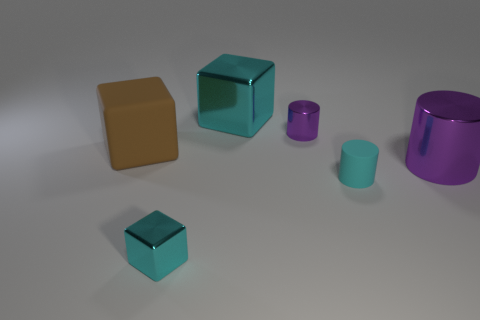Are the purple cylinder that is on the left side of the tiny cyan matte cylinder and the thing to the right of the small matte cylinder made of the same material?
Offer a very short reply. Yes. There is a big object behind the brown matte cube; is there a small cylinder that is behind it?
Your answer should be very brief. No. What color is the big cube that is the same material as the small cyan cylinder?
Your answer should be compact. Brown. Is the number of tiny purple shiny things greater than the number of big gray rubber cubes?
Make the answer very short. Yes. What number of things are small metal cylinders that are behind the cyan rubber cylinder or tiny yellow cylinders?
Your answer should be very brief. 1. Is there a red object of the same size as the rubber block?
Offer a terse response. No. Is the number of cyan blocks less than the number of cylinders?
Your response must be concise. Yes. What number of balls are either large cyan metallic objects or large brown rubber objects?
Your answer should be compact. 0. How many shiny cylinders are the same color as the big matte block?
Offer a very short reply. 0. What is the size of the thing that is to the left of the large cyan metallic cube and behind the large shiny cylinder?
Offer a terse response. Large. 